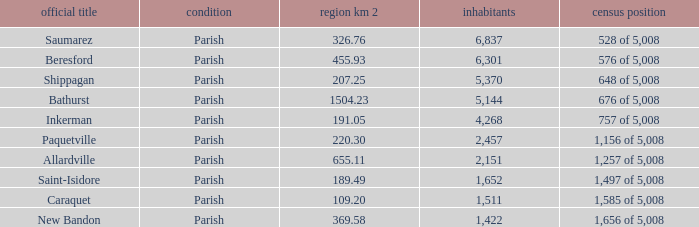What is the Area of the Allardville Parish with a Population smaller than 2,151? None. 